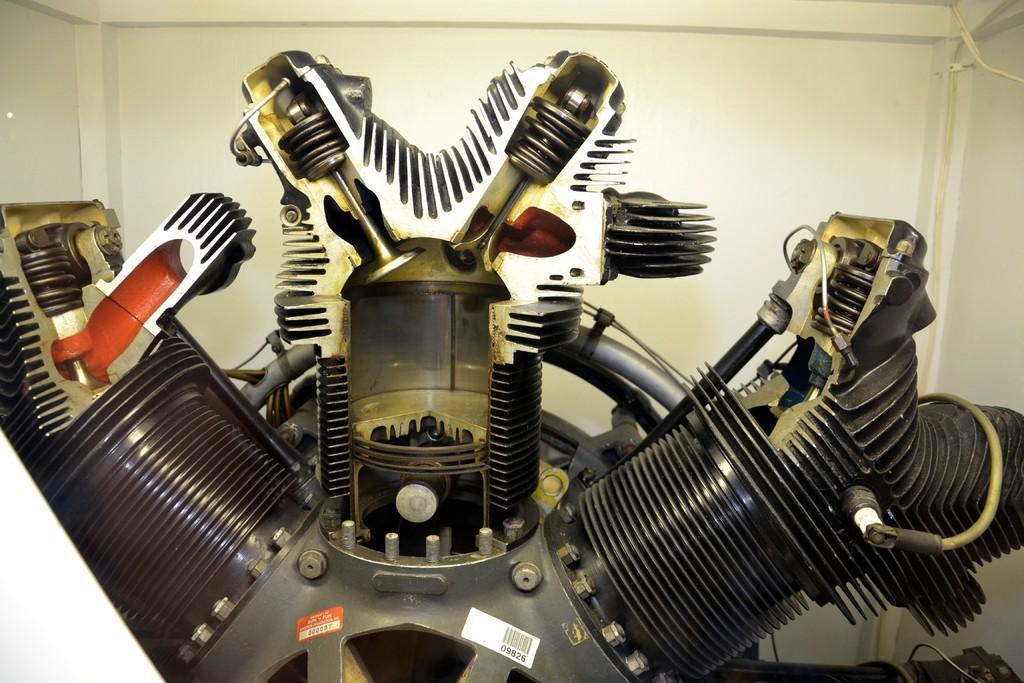Can you describe this image briefly? In this image I can see a machine tool. In the background there is a wall. 